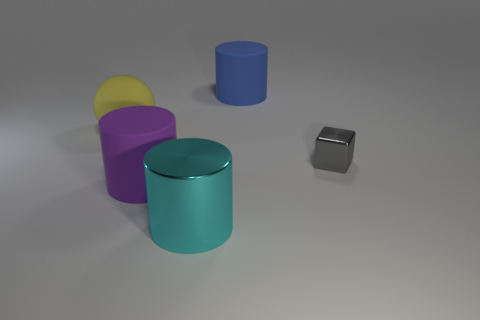Subtract all large rubber cylinders. How many cylinders are left? 1 Subtract 1 cylinders. How many cylinders are left? 2 Add 3 small brown rubber cylinders. How many objects exist? 8 Subtract all blue cylinders. How many cylinders are left? 2 Subtract all brown spheres. Subtract all green cylinders. How many spheres are left? 1 Subtract all blue balls. How many purple cubes are left? 0 Subtract all tiny yellow metallic objects. Subtract all yellow rubber things. How many objects are left? 4 Add 2 purple matte cylinders. How many purple matte cylinders are left? 3 Add 1 red matte cubes. How many red matte cubes exist? 1 Subtract 0 gray cylinders. How many objects are left? 5 